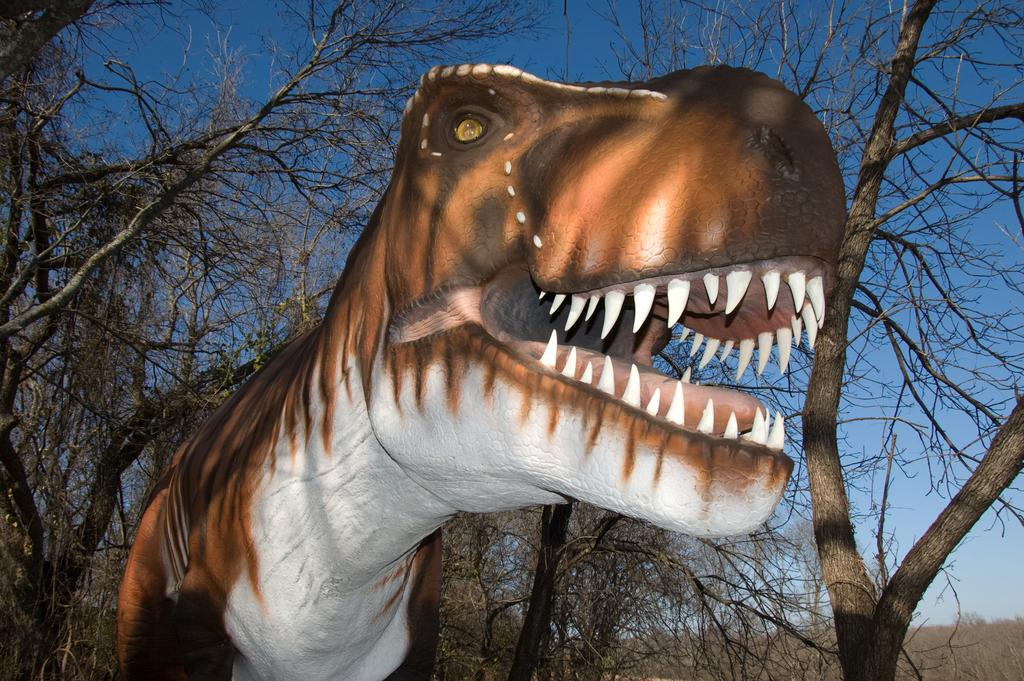What is there is a picture of what animal in the image? There is a picture of a dinosaur in the image. What can be seen in the background of the image? There are trees behind the dinosaur in the image. How does the dinosaur help the sister in the image? There is no sister present in the image, and the dinosaur is a picture, so it cannot help anyone. 